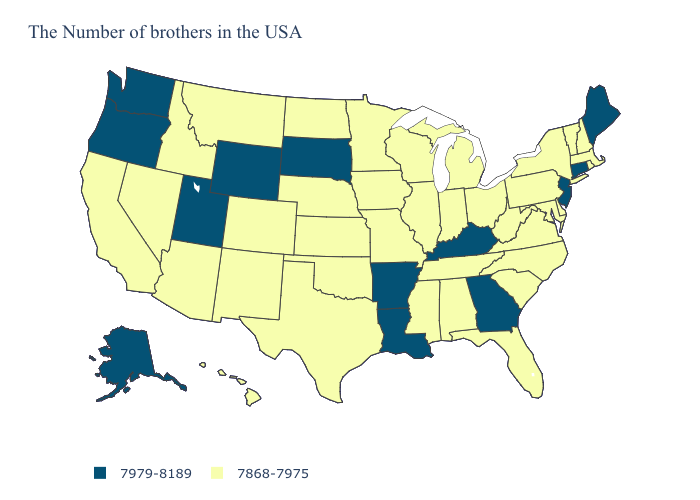Name the states that have a value in the range 7979-8189?
Answer briefly. Maine, Connecticut, New Jersey, Georgia, Kentucky, Louisiana, Arkansas, South Dakota, Wyoming, Utah, Washington, Oregon, Alaska. What is the value of Texas?
Concise answer only. 7868-7975. Which states have the highest value in the USA?
Concise answer only. Maine, Connecticut, New Jersey, Georgia, Kentucky, Louisiana, Arkansas, South Dakota, Wyoming, Utah, Washington, Oregon, Alaska. What is the lowest value in the MidWest?
Answer briefly. 7868-7975. Which states have the lowest value in the USA?
Write a very short answer. Massachusetts, Rhode Island, New Hampshire, Vermont, New York, Delaware, Maryland, Pennsylvania, Virginia, North Carolina, South Carolina, West Virginia, Ohio, Florida, Michigan, Indiana, Alabama, Tennessee, Wisconsin, Illinois, Mississippi, Missouri, Minnesota, Iowa, Kansas, Nebraska, Oklahoma, Texas, North Dakota, Colorado, New Mexico, Montana, Arizona, Idaho, Nevada, California, Hawaii. Among the states that border Wisconsin , which have the lowest value?
Concise answer only. Michigan, Illinois, Minnesota, Iowa. Does the first symbol in the legend represent the smallest category?
Answer briefly. No. Name the states that have a value in the range 7979-8189?
Be succinct. Maine, Connecticut, New Jersey, Georgia, Kentucky, Louisiana, Arkansas, South Dakota, Wyoming, Utah, Washington, Oregon, Alaska. Among the states that border Wyoming , does South Dakota have the highest value?
Keep it brief. Yes. Among the states that border Florida , which have the highest value?
Give a very brief answer. Georgia. What is the lowest value in the West?
Concise answer only. 7868-7975. What is the highest value in the West ?
Short answer required. 7979-8189. How many symbols are there in the legend?
Be succinct. 2. Does Oregon have the highest value in the West?
Answer briefly. Yes. 